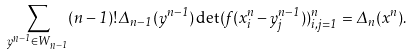Convert formula to latex. <formula><loc_0><loc_0><loc_500><loc_500>\sum _ { y ^ { n - 1 } \in W _ { n - 1 } } ( n - 1 ) ! \Delta _ { n - 1 } ( y ^ { n - 1 } ) \det ( f ( x _ { i } ^ { n } - y _ { j } ^ { n - 1 } ) ) _ { i , j = 1 } ^ { n } = \Delta _ { n } ( x ^ { n } ) .</formula> 